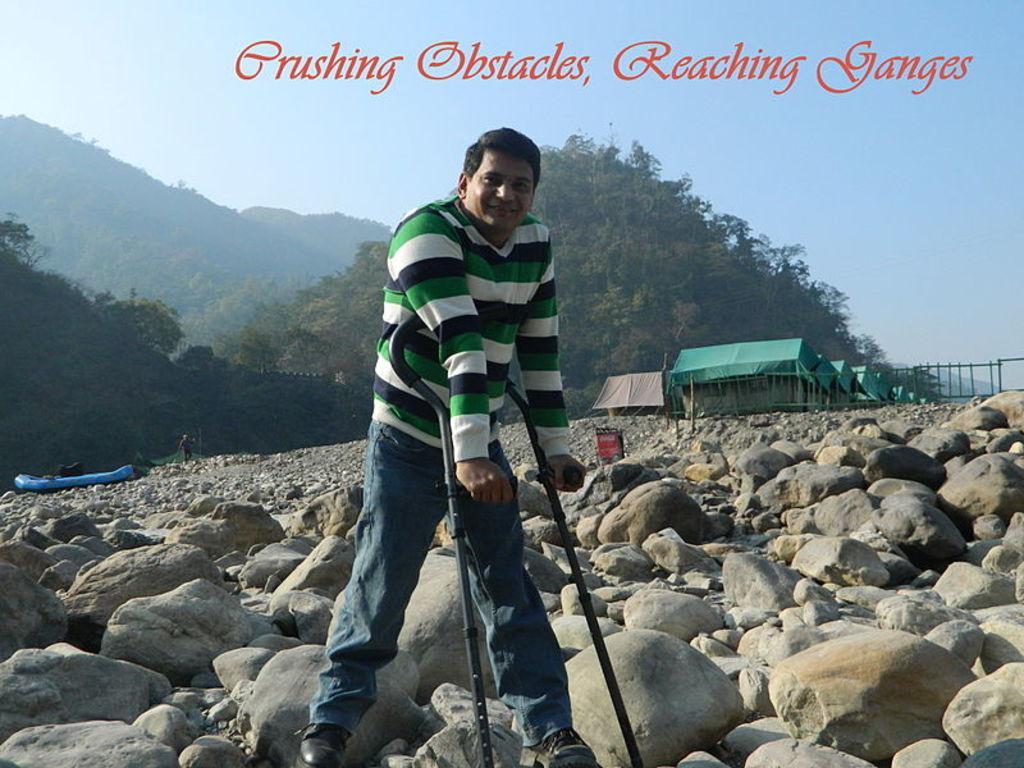How would you summarize this image in a sentence or two? In the center of the image there is a person standing on the stones with walking sticks. In the background there are tents, hills, person and sky. At the bottom of the image there are stones. At the top there is a text. 